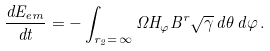Convert formula to latex. <formula><loc_0><loc_0><loc_500><loc_500>\frac { d E _ { e m } } { d t } = - \int _ { r _ { 2 } = \, \infty } \Omega H _ { \varphi } B ^ { r } \sqrt { \gamma } \, d \theta \, d \varphi \, .</formula> 